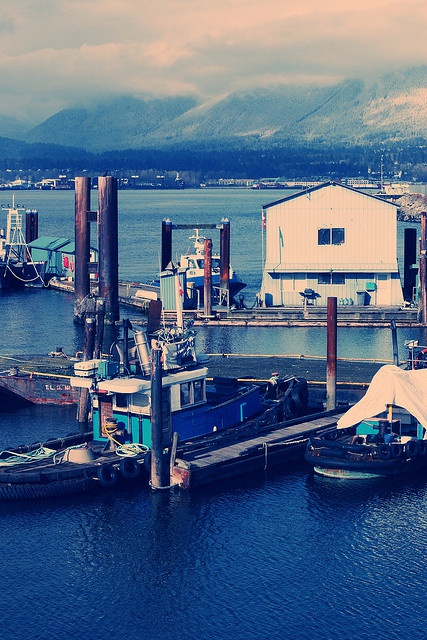Describe the objects in this image and their specific colors. I can see boat in darkgray, navy, and blue tones, boat in darkgray, navy, and tan tones, boat in darkgray, purple, navy, blue, and gray tones, and boat in darkgray, navy, tan, and blue tones in this image. 